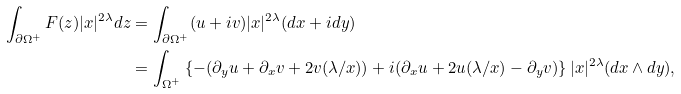Convert formula to latex. <formula><loc_0><loc_0><loc_500><loc_500>\int _ { \partial \Omega ^ { + } } F ( z ) | x | ^ { 2 \lambda } d z & = \int _ { \partial \Omega ^ { + } } ( u + i v ) | x | ^ { 2 \lambda } ( d x + i d y ) \\ & = \int _ { \Omega ^ { + } } \left \{ - ( \partial _ { y } u + \partial _ { x } v + 2 v ( \lambda / x ) ) + i ( \partial _ { x } u + 2 u ( \lambda / x ) - \partial _ { y } v ) \right \} | x | ^ { 2 \lambda } ( d x \wedge d y ) , \\</formula> 